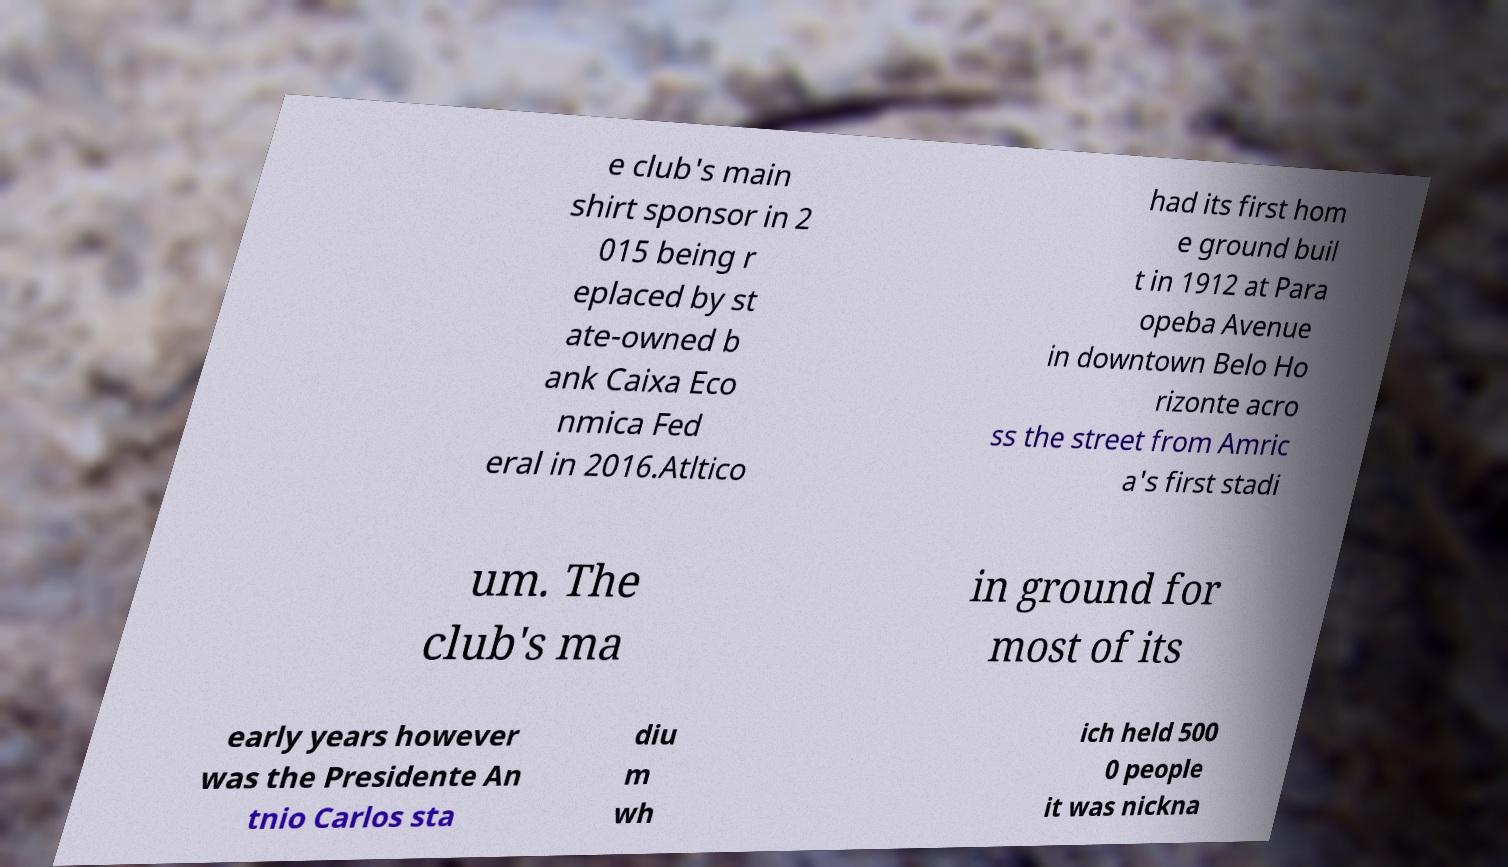I need the written content from this picture converted into text. Can you do that? e club's main shirt sponsor in 2 015 being r eplaced by st ate-owned b ank Caixa Eco nmica Fed eral in 2016.Atltico had its first hom e ground buil t in 1912 at Para opeba Avenue in downtown Belo Ho rizonte acro ss the street from Amric a's first stadi um. The club's ma in ground for most of its early years however was the Presidente An tnio Carlos sta diu m wh ich held 500 0 people it was nickna 